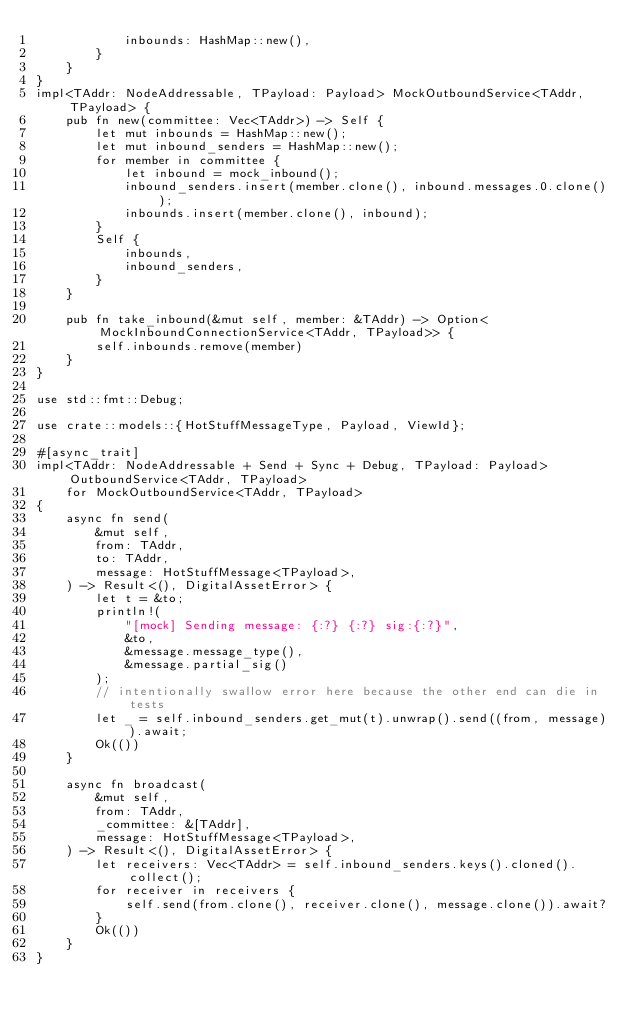<code> <loc_0><loc_0><loc_500><loc_500><_Rust_>            inbounds: HashMap::new(),
        }
    }
}
impl<TAddr: NodeAddressable, TPayload: Payload> MockOutboundService<TAddr, TPayload> {
    pub fn new(committee: Vec<TAddr>) -> Self {
        let mut inbounds = HashMap::new();
        let mut inbound_senders = HashMap::new();
        for member in committee {
            let inbound = mock_inbound();
            inbound_senders.insert(member.clone(), inbound.messages.0.clone());
            inbounds.insert(member.clone(), inbound);
        }
        Self {
            inbounds,
            inbound_senders,
        }
    }

    pub fn take_inbound(&mut self, member: &TAddr) -> Option<MockInboundConnectionService<TAddr, TPayload>> {
        self.inbounds.remove(member)
    }
}

use std::fmt::Debug;

use crate::models::{HotStuffMessageType, Payload, ViewId};

#[async_trait]
impl<TAddr: NodeAddressable + Send + Sync + Debug, TPayload: Payload> OutboundService<TAddr, TPayload>
    for MockOutboundService<TAddr, TPayload>
{
    async fn send(
        &mut self,
        from: TAddr,
        to: TAddr,
        message: HotStuffMessage<TPayload>,
    ) -> Result<(), DigitalAssetError> {
        let t = &to;
        println!(
            "[mock] Sending message: {:?} {:?} sig:{:?}",
            &to,
            &message.message_type(),
            &message.partial_sig()
        );
        // intentionally swallow error here because the other end can die in tests
        let _ = self.inbound_senders.get_mut(t).unwrap().send((from, message)).await;
        Ok(())
    }

    async fn broadcast(
        &mut self,
        from: TAddr,
        _committee: &[TAddr],
        message: HotStuffMessage<TPayload>,
    ) -> Result<(), DigitalAssetError> {
        let receivers: Vec<TAddr> = self.inbound_senders.keys().cloned().collect();
        for receiver in receivers {
            self.send(from.clone(), receiver.clone(), message.clone()).await?
        }
        Ok(())
    }
}
</code> 